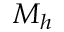<formula> <loc_0><loc_0><loc_500><loc_500>M _ { h }</formula> 